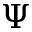Convert formula to latex. <formula><loc_0><loc_0><loc_500><loc_500>\Psi</formula> 